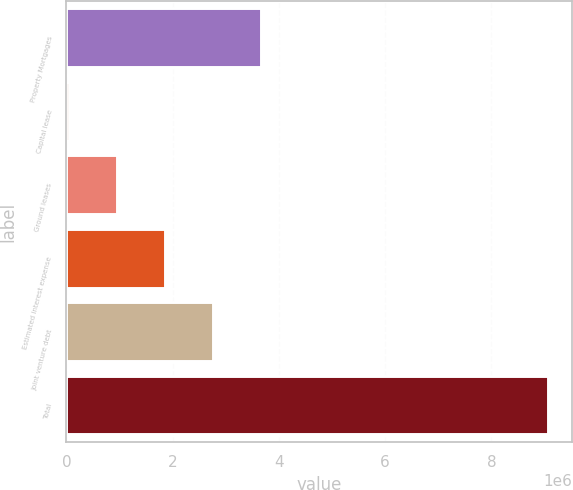Convert chart to OTSL. <chart><loc_0><loc_0><loc_500><loc_500><bar_chart><fcel>Property Mortgages<fcel>Capital lease<fcel>Ground leases<fcel>Estimated interest expense<fcel>Joint venture debt<fcel>Total<nl><fcel>3.65618e+06<fcel>51869<fcel>952947<fcel>1.85403e+06<fcel>2.7551e+06<fcel>9.06265e+06<nl></chart> 